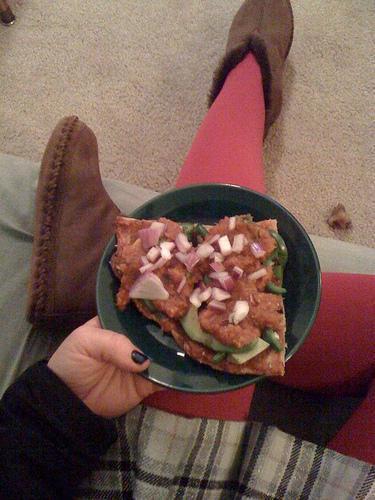How many feet are in the photo?
Give a very brief answer. 2. 